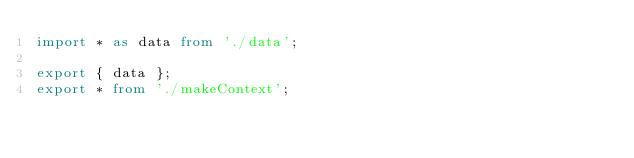Convert code to text. <code><loc_0><loc_0><loc_500><loc_500><_TypeScript_>import * as data from './data';

export { data };
export * from './makeContext';
</code> 